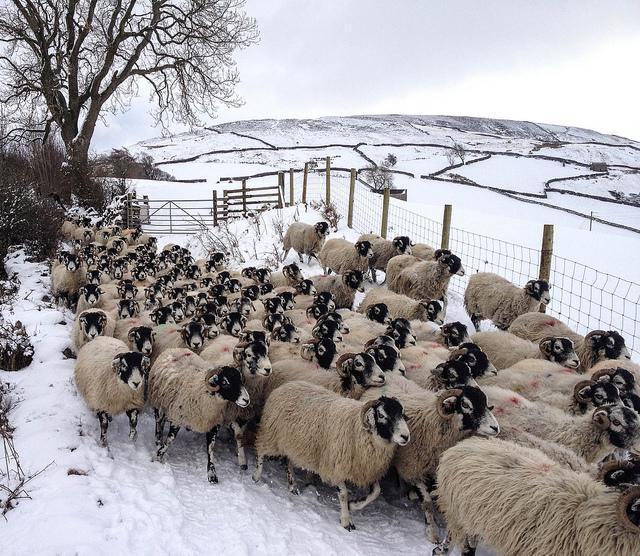How many sheep are visible?
Give a very brief answer. 11. How many buses are on the street?
Give a very brief answer. 0. 